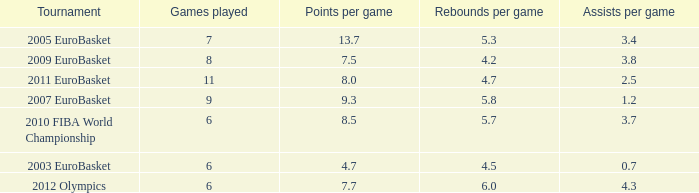How many points per game have the tournament 2005 eurobasket? 13.7. 